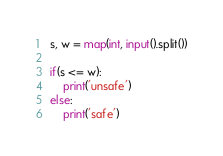Convert code to text. <code><loc_0><loc_0><loc_500><loc_500><_Python_>s, w = map(int, input().split())

if(s <= w):
    print('unsafe')
else:
    print('safe')
</code> 